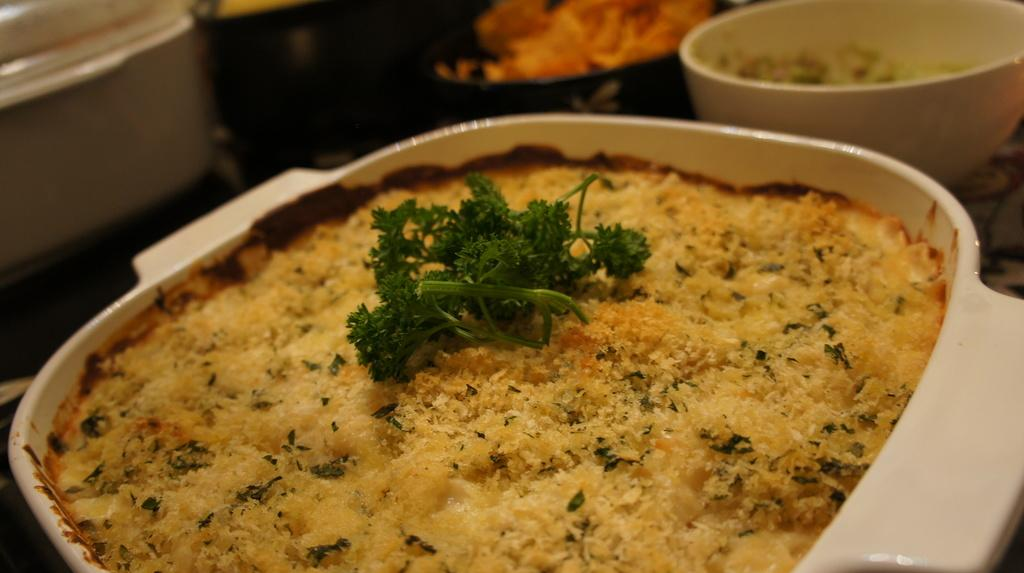What type of objects are present in the image? There are food items in the image. How are the food items contained or displayed? The food items are in a white color bowl. What type of garnish is present on the food items? There are coriander leaves on the food items. What type of mailbox can be seen in the image? There is no mailbox present in the image; it features food items in a white bowl with coriander leaves. 